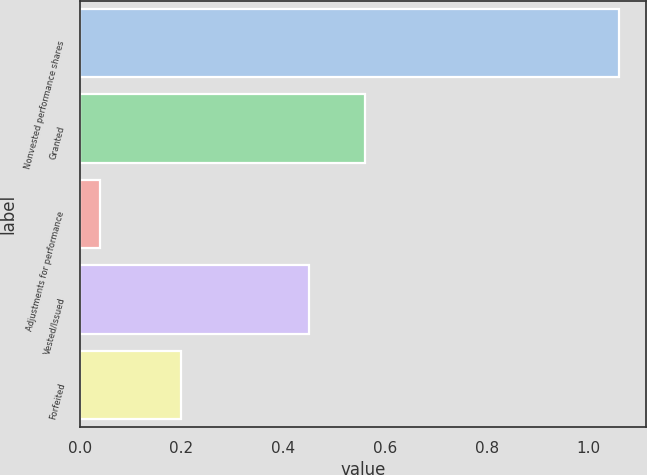<chart> <loc_0><loc_0><loc_500><loc_500><bar_chart><fcel>Nonvested performance shares<fcel>Granted<fcel>Adjustments for performance<fcel>Vested/Issued<fcel>Forfeited<nl><fcel>1.06<fcel>0.56<fcel>0.04<fcel>0.45<fcel>0.2<nl></chart> 